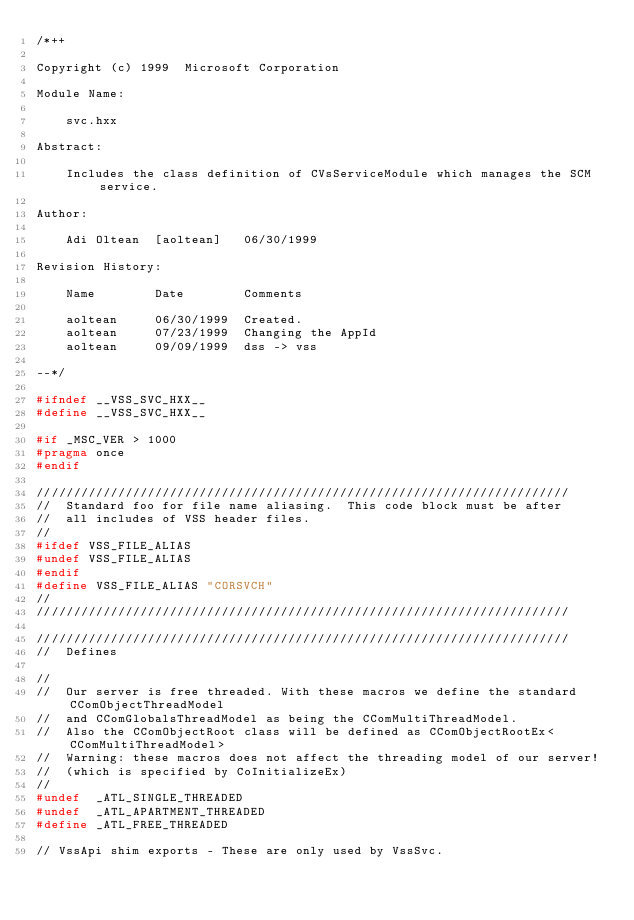<code> <loc_0><loc_0><loc_500><loc_500><_C++_>/*++

Copyright (c) 1999  Microsoft Corporation

Module Name:

    svc.hxx

Abstract:

    Includes the class definition of CVsServiceModule which manages the SCM service.

Author:

    Adi Oltean  [aoltean]   06/30/1999

Revision History:

    Name        Date        Comments

    aoltean     06/30/1999  Created.
    aoltean     07/23/1999  Changing the AppId
    aoltean     09/09/1999  dss -> vss

--*/

#ifndef __VSS_SVC_HXX__
#define __VSS_SVC_HXX__

#if _MSC_VER > 1000
#pragma once
#endif

////////////////////////////////////////////////////////////////////////
//  Standard foo for file name aliasing.  This code block must be after
//  all includes of VSS header files.
//
#ifdef VSS_FILE_ALIAS
#undef VSS_FILE_ALIAS
#endif
#define VSS_FILE_ALIAS "CORSVCH"
//
////////////////////////////////////////////////////////////////////////

////////////////////////////////////////////////////////////////////////
//  Defines

//
//  Our server is free threaded. With these macros we define the standard CComObjectThreadModel 
//  and CComGlobalsThreadModel as being the CComMultiThreadModel.
//  Also the CComObjectRoot class will be defined as CComObjectRootEx<CComMultiThreadModel> 
//  Warning: these macros does not affect the threading model of our server! 
//	(which is specified by CoInitializeEx)
//
#undef  _ATL_SINGLE_THREADED
#undef  _ATL_APARTMENT_THREADED
#define _ATL_FREE_THREADED

// VssApi shim exports - These are only used by VssSvc.</code> 